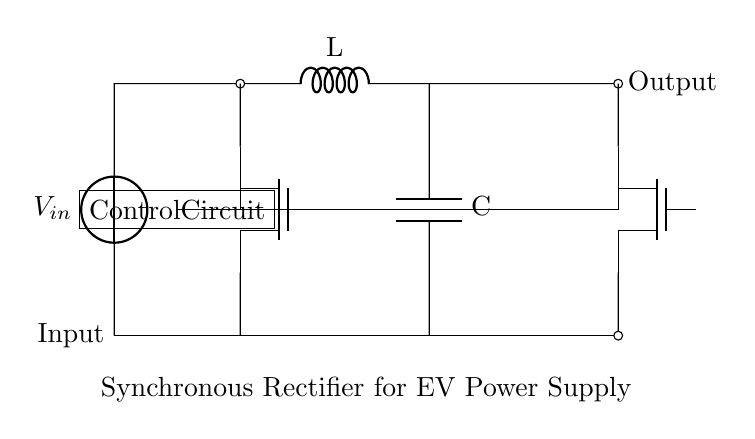What is the input component of this circuit? The input component is a voltage source, which is labeled as V_in in the diagram.
Answer: voltage source What type of transistors are used in this synchronous rectifier circuit? The circuit uses N-channel MOSFETs, indicated by the Tnmos notation for the devices labeled Q1 and Q2.
Answer: N-channel MOSFETs How many inductors are present in the circuit? There is one inductor in the circuit, marked as L.
Answer: one What is the role of the control circuit in this diagram? The control circuit is responsible for managing the operation of the N-channel MOSFETs, ensuring they switch on and off in sync with the input voltage to improve efficiency.
Answer: manage MOSFET operation Why is a synchronous rectifier used in electric vehicle power supplies? A synchronous rectifier improves efficiency by reducing conduction losses compared to traditional diodes, making it ideal for applications like electric vehicle power supplies where energy efficiency is critical.
Answer: improve efficiency What is the output component in this circuit? The output component comprises the connection points after the inductors and control circuitry, effectively acting as the output terminals for the power supply.
Answer: output terminals What is the function of the capacitor in the circuit? The capacitor, labeled C, smooths out voltage fluctuations and stabilizes the output, ensuring a steady voltage supply to the load.
Answer: smooth voltage fluctuations 